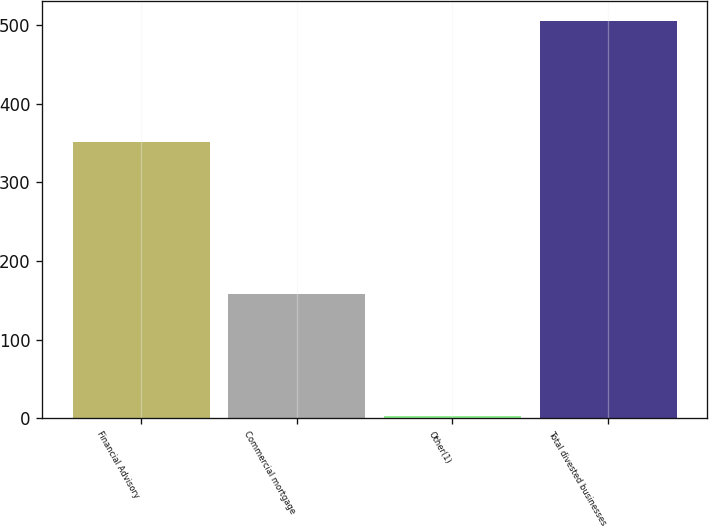Convert chart. <chart><loc_0><loc_0><loc_500><loc_500><bar_chart><fcel>Financial Advisory<fcel>Commercial mortgage<fcel>Other(1)<fcel>Total divested businesses<nl><fcel>351<fcel>158<fcel>3<fcel>506<nl></chart> 